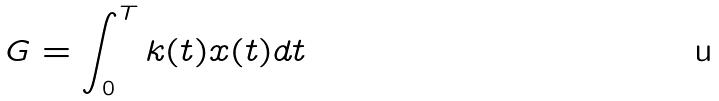<formula> <loc_0><loc_0><loc_500><loc_500>G = \int _ { 0 } ^ { T } k ( t ) x ( t ) d t</formula> 